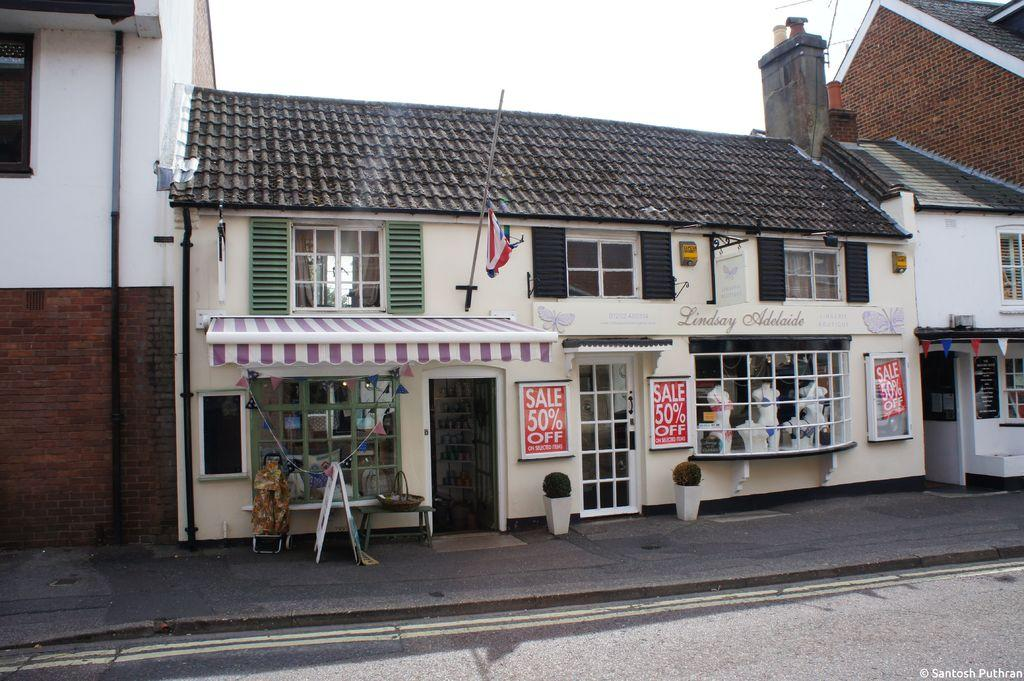What type of structures are visible in the image? There are buildings in the image. What is located in front of the buildings? There is a road in front of the image. Is there any symbol or decoration on the buildings? Yes, a flag is attached to one of the buildings. How many oranges are being added to the memory of the buildings in the image? There are no oranges or references to memory in the image; it only features buildings, a road, and a flag. 